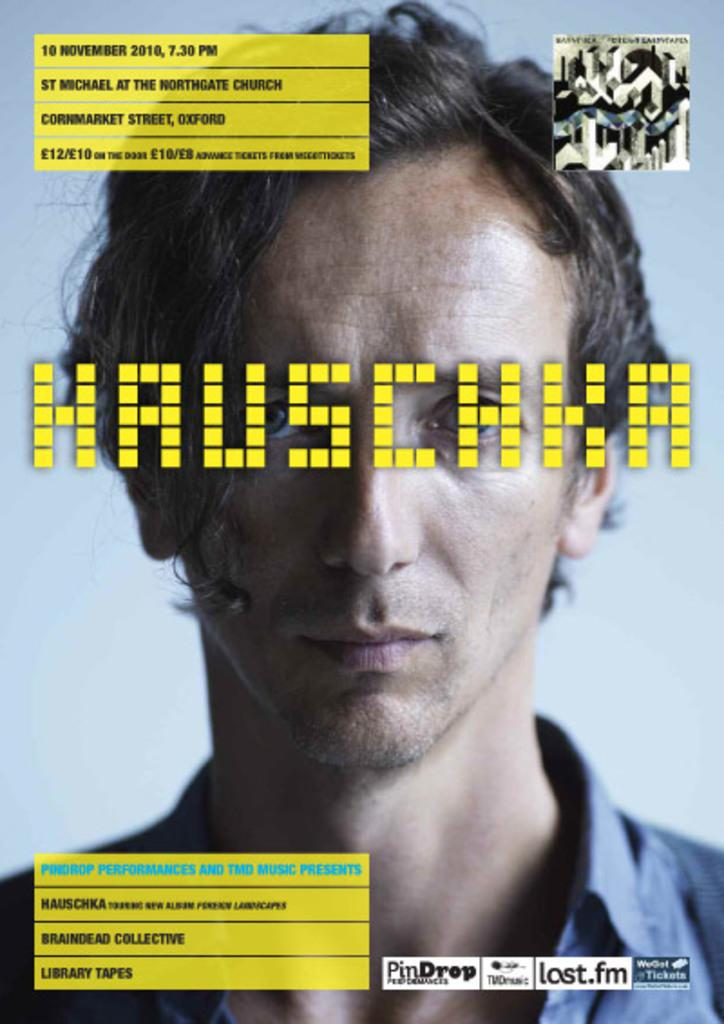How many watermarks are present in the image? There are three watermarks present in the image. Where are the watermarks located in the image? The watermarks are located in the middle, at the top, and at the bottom of the image. Can you describe the person in the background of the image? Unfortunately, the provided facts do not give any information about the person in the background. What type of soap is being used by the person in the image? There is no person or soap present in the image, as the facts only mention the presence of watermarks. 